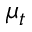Convert formula to latex. <formula><loc_0><loc_0><loc_500><loc_500>\mu _ { t }</formula> 